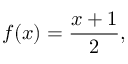<formula> <loc_0><loc_0><loc_500><loc_500>f ( x ) = { \frac { x + 1 } { 2 } } ,</formula> 